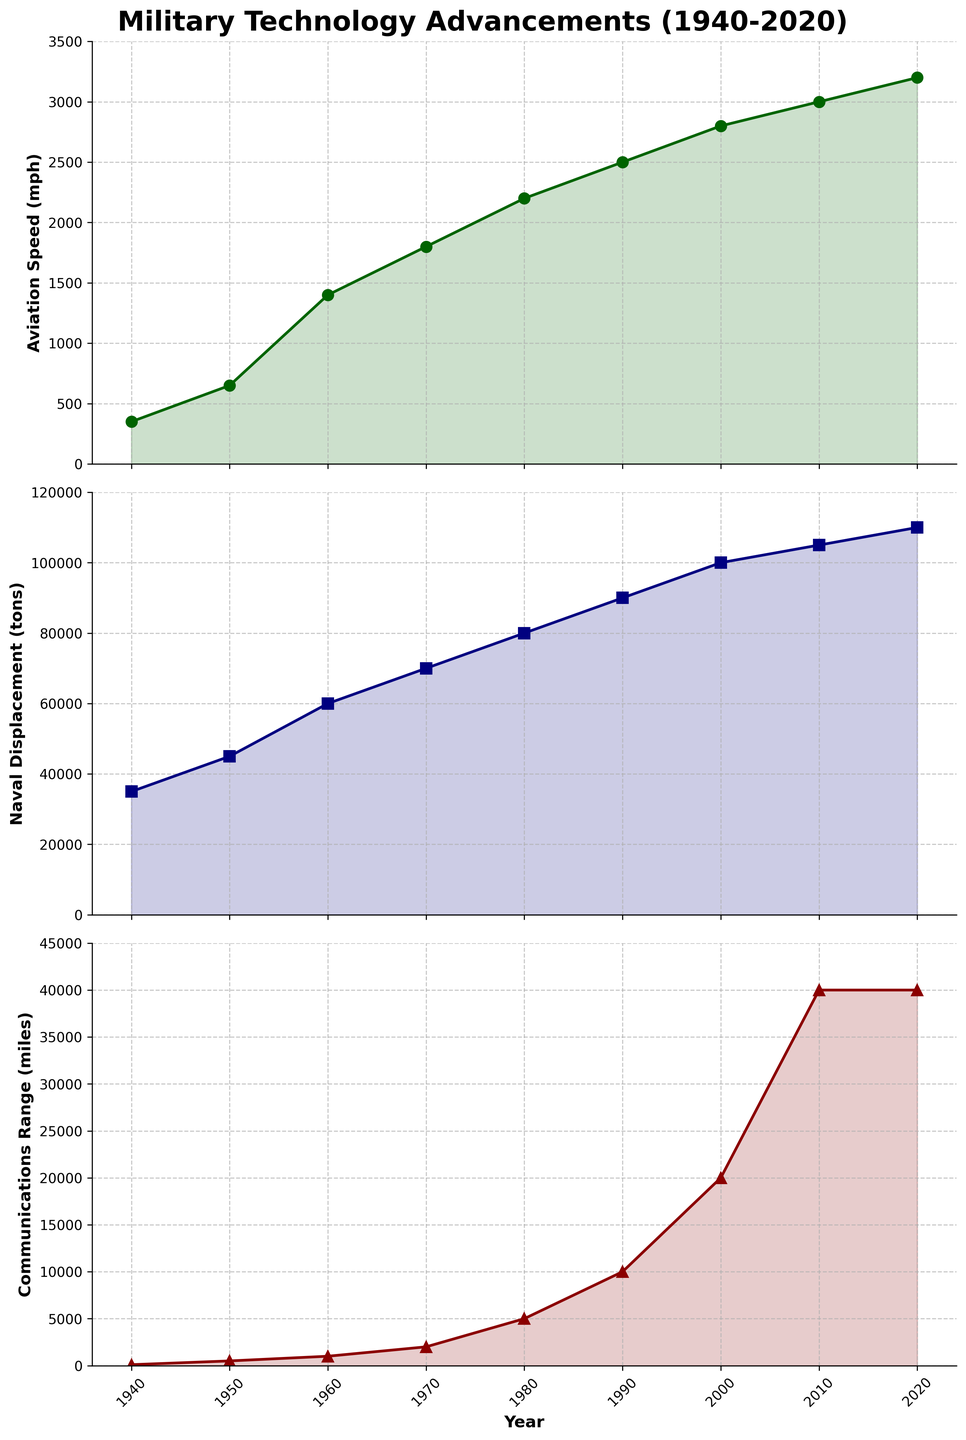Which field shows the highest increase in technological advancement between 1940 and 2020? By visually comparing the three subplots: Aviation Speed, Naval Displacement, and Communications Range, it is evident that despite significant advancements in all fields, Communications Range seems to have the highest increase, especially with 'Global' capabilities achieved by 2010.
Answer: Communications Range What is the maximum speed recorded for aviation by 2020? The data values on the Aviation Speed plot indicate the highest point in the year 2020 at 3200 mph.
Answer: 3200 mph By how much did Naval Displacement (tons) increase between 1960 and 1980? Naval Displacement in 1960 was 60,000 tons, and in 1980 it increased to 80,000 tons. The increase is calculated as 80,000 - 60,000.
Answer: 20,000 tons Which year marks the first global communications capability according to the plot? The Communications Range subplot shows that from 2010 onwards, the plot labels "Global" capability.
Answer: 2010 Which field shows a relatively continuous and consistent rate of improvement from 1940 to 2020? The subplots for both Naval Displacement and Communications Range show consistent upward trends, but Aviation Speed has a more fluctuating increase initially. Thus, Naval Displacement displays a more consistent rate of improvement.
Answer: Naval Displacement What was the Aviation Speed (in mph) in the year 1960? The Aviation Speed subplot shows a data point corresponding to 1960 at 1400 mph.
Answer: 1400 mph By what factor did the Communications Range (miles) increase from 1940 to 1990? In 1940, the Communications Range was 100 miles and in 1990 it was 10,000 miles. The factor of increase is 10,000 / 100.
Answer: 100 Compare the relative growth of Aviation Speed and Naval Displacement from 1940 to 1970. Which field expanded more rapidly? Aviation Speed increased from 350 mph to 1800 mph, while Naval Displacement rose from 35,000 tons to 70,000 tons from 1940 to 1970. Calculating the rate, (1,800 - 350)/350 for Aviation Speed and (70,000 - 35,000)/35,000 for Naval Displacement, the growth rate for Aviation Speed is higher.
Answer: Aviation Speed In which decade did Communications Range see the most significant increase? The Communications Range subplot indicates the most steep increase from the 1980s to the 1990s, jumping from 5,000 to 10,000 miles.
Answer: 1980s-1990s 